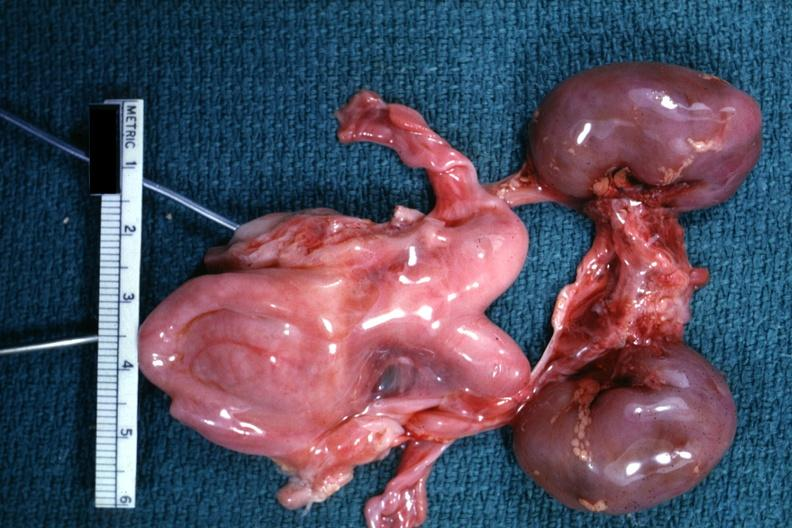what is present?
Answer the question using a single word or phrase. Uterus 